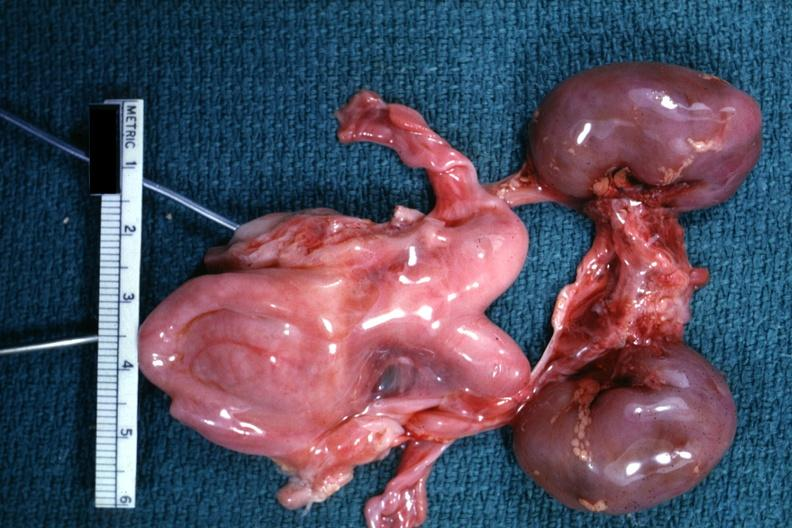what is present?
Answer the question using a single word or phrase. Uterus 